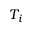Convert formula to latex. <formula><loc_0><loc_0><loc_500><loc_500>T _ { i }</formula> 